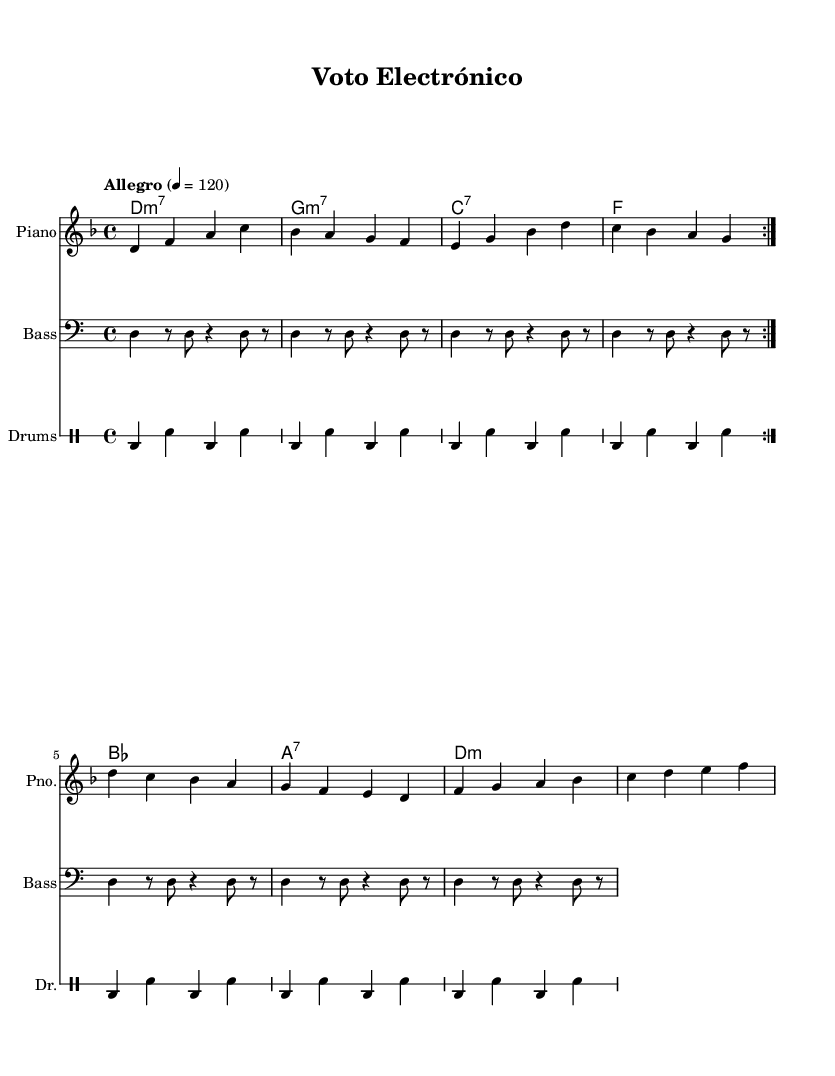What is the key signature of this music? The key signature is indicated by the symbol at the beginning of the staff. In this case, it appears to be D minor, which has one flat (C).
Answer: D minor What is the time signature of this music? The time signature is located at the beginning of the piece, showing how many beats are in each measure. Here, it is 4/4, meaning there are four beats per measure.
Answer: 4/4 What is the tempo marking for this piece? The tempo can be found above the staff labeled "Allegro" with a metronome indication of 4 = 120, meaning the piece should be played at a speed of 120 beats per minute.
Answer: Allegro, 120 How many times is the melody repeated? The repeat indication is present in the melody section, showing "volta 2," which specifies that the melody part is repeated twice in total.
Answer: 2 What are the chord changes for the first two measures? The chords in the first two measures are D minor 7 and G minor 7. These chords can be identified by their labels in the chord names below the melody staff.
Answer: D minor 7, G minor 7 What is the primary instrumental focus of this fusion piece? By examining the score layout, the presence of a piano staff, a bass staff, and a drum staff indicates that piano leads the melody with bass and drums contributing rhythm and harmony.
Answer: Piano 